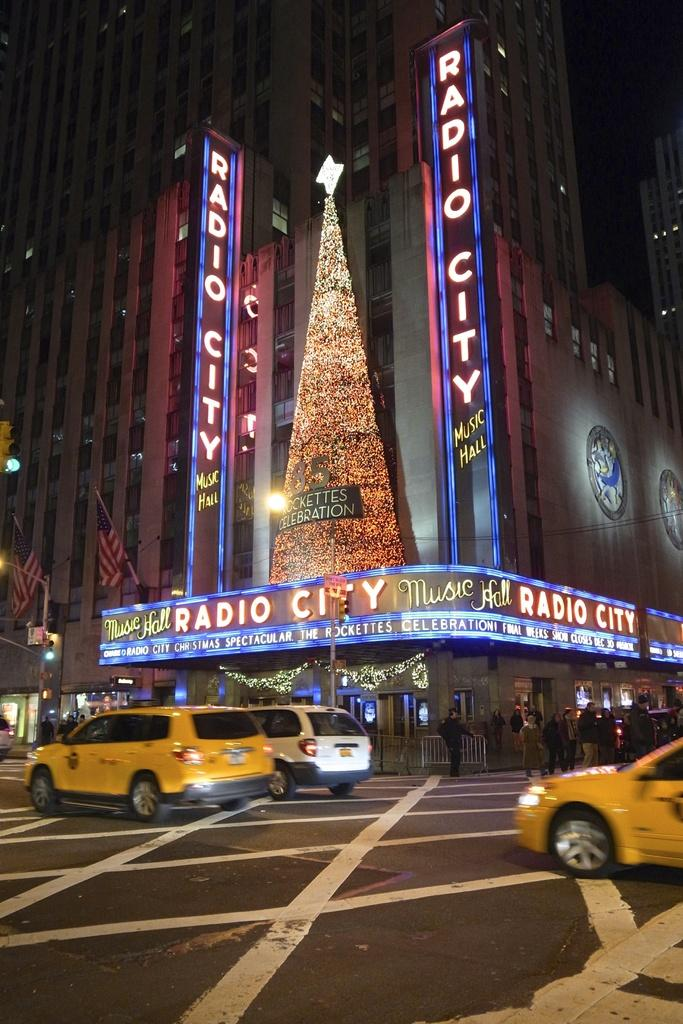<image>
Write a terse but informative summary of the picture. The Rocketts performing at Radio City with a sign saying the show closes Dec 30. 